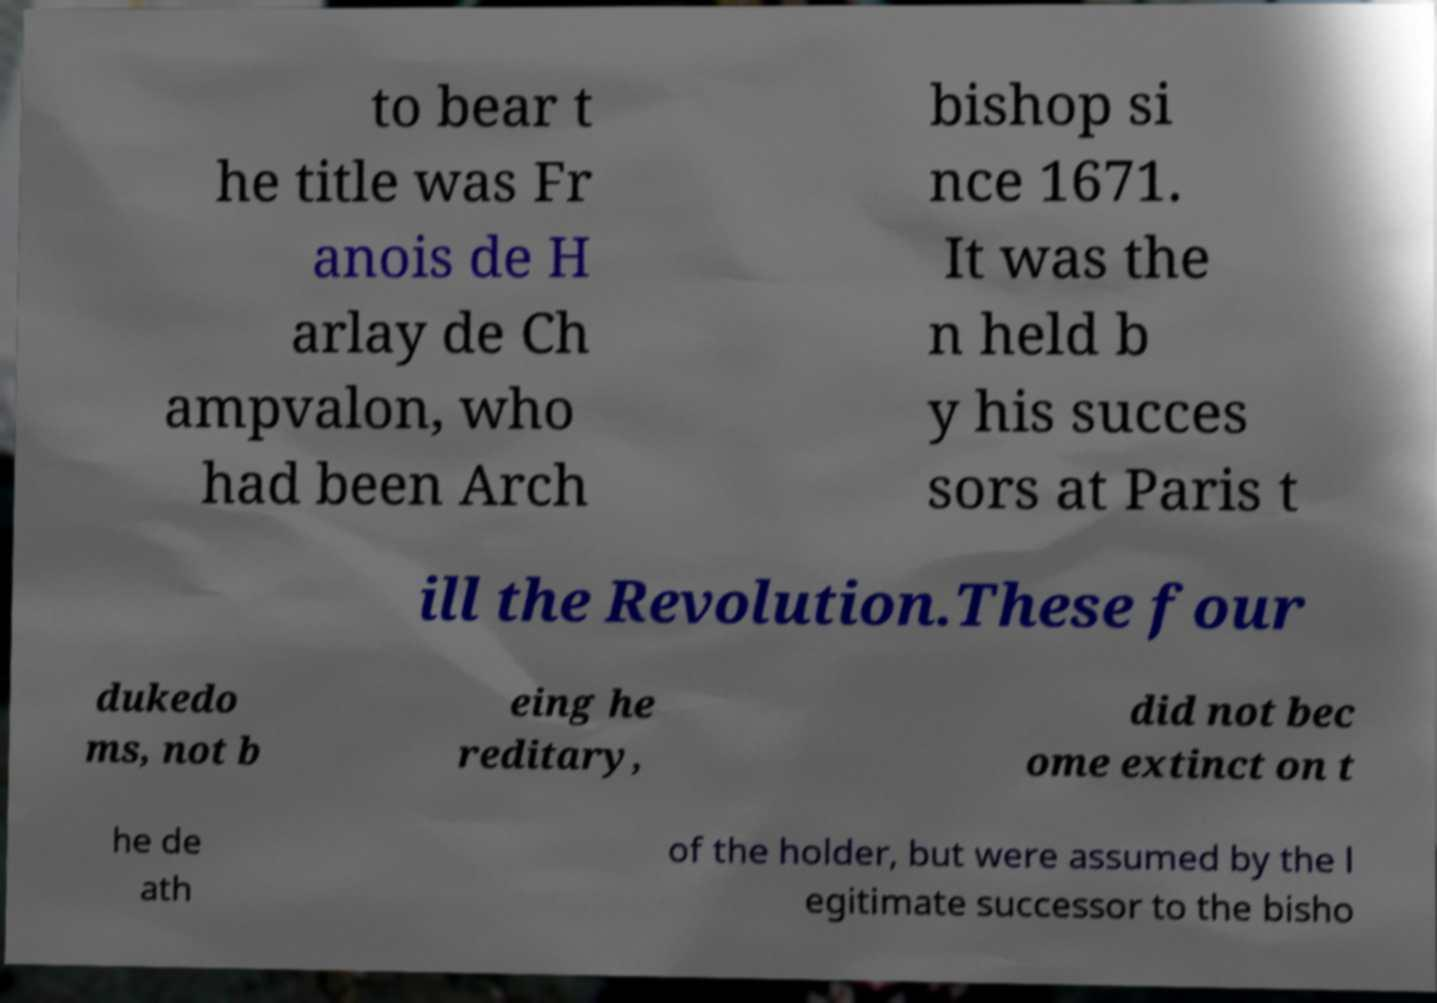Please read and relay the text visible in this image. What does it say? to bear t he title was Fr anois de H arlay de Ch ampvalon, who had been Arch bishop si nce 1671. It was the n held b y his succes sors at Paris t ill the Revolution.These four dukedo ms, not b eing he reditary, did not bec ome extinct on t he de ath of the holder, but were assumed by the l egitimate successor to the bisho 